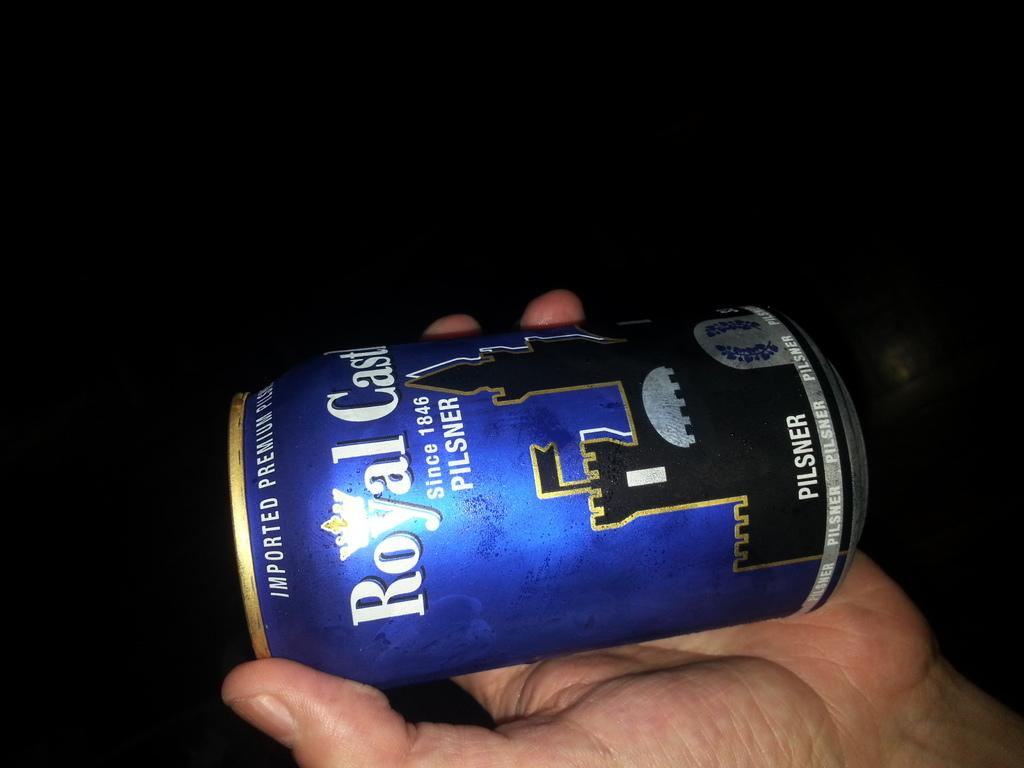<image>
Summarize the visual content of the image. a bottle of beer called roayl castle looks like someone is holding it 